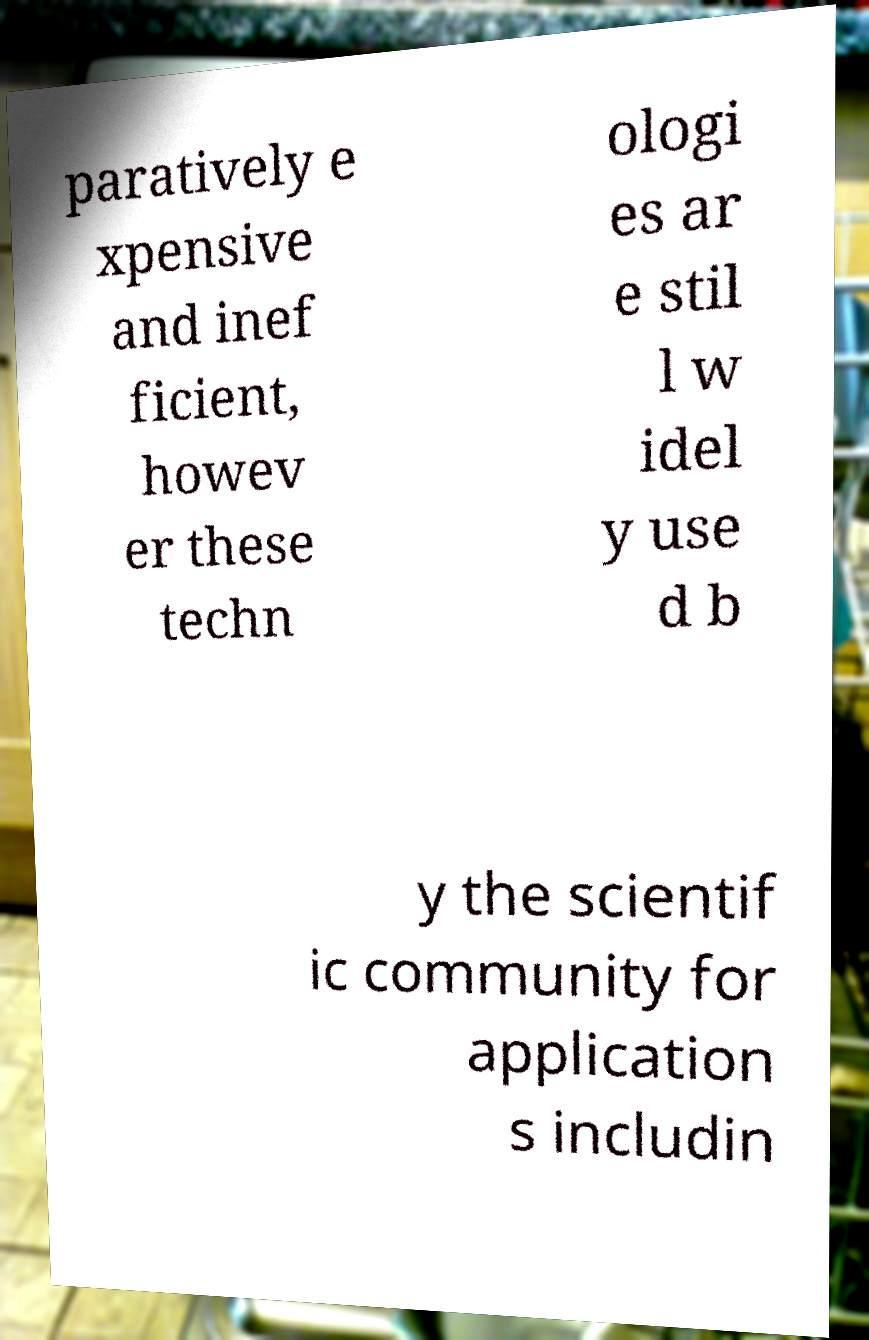Please read and relay the text visible in this image. What does it say? paratively e xpensive and inef ficient, howev er these techn ologi es ar e stil l w idel y use d b y the scientif ic community for application s includin 